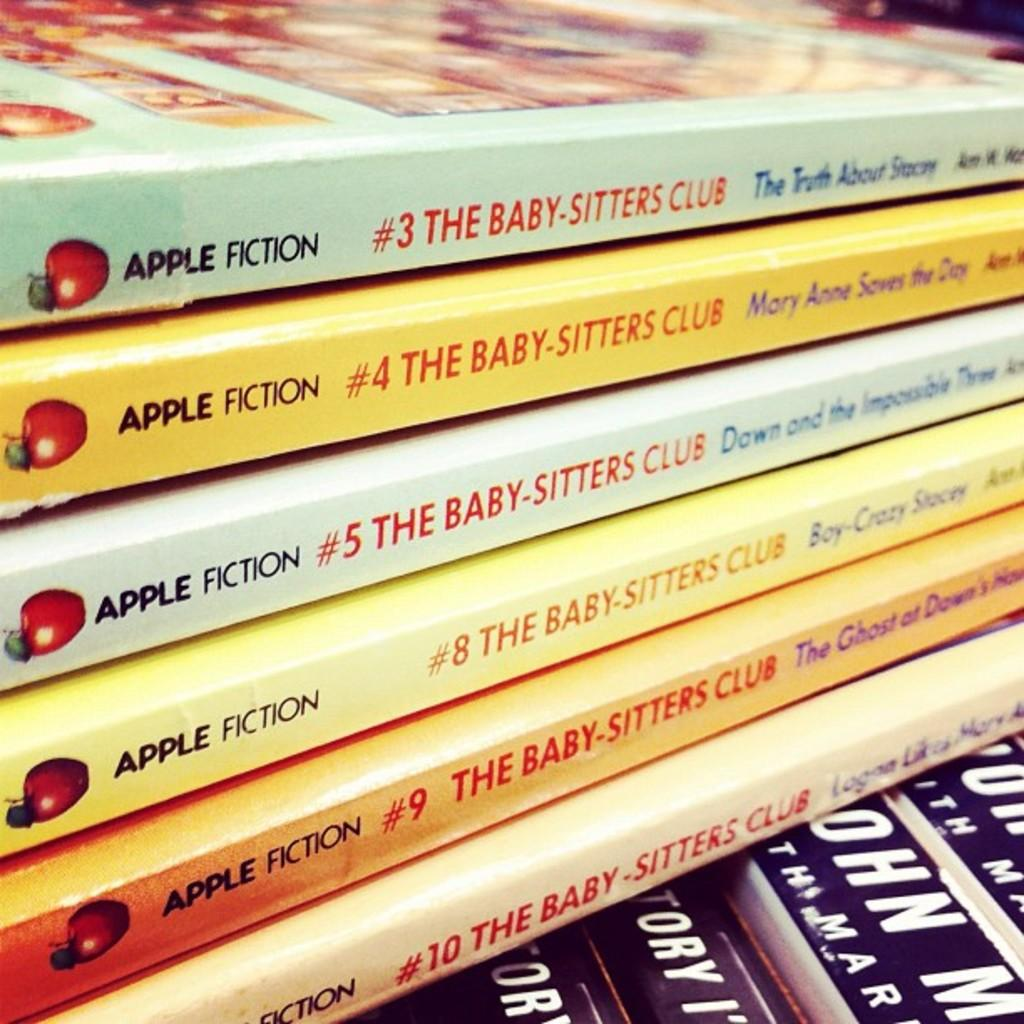<image>
Provide a brief description of the given image. Different volumes of The Baby-Sitters club lie on top of eat other. 